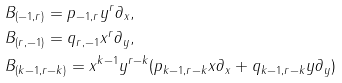<formula> <loc_0><loc_0><loc_500><loc_500>& B _ { ( - 1 , r ) } = p _ { - 1 , r } y ^ { r } \partial _ { x } , \\ & B _ { ( r , - 1 ) } = q _ { r , - 1 } x ^ { r } \partial _ { y } , \\ & B _ { ( k - 1 , r - k ) } = x ^ { k - 1 } y ^ { r - k } ( p _ { k - 1 , r - k } x \partial _ { x } + q _ { k - 1 , r - k } y \partial _ { y } )</formula> 